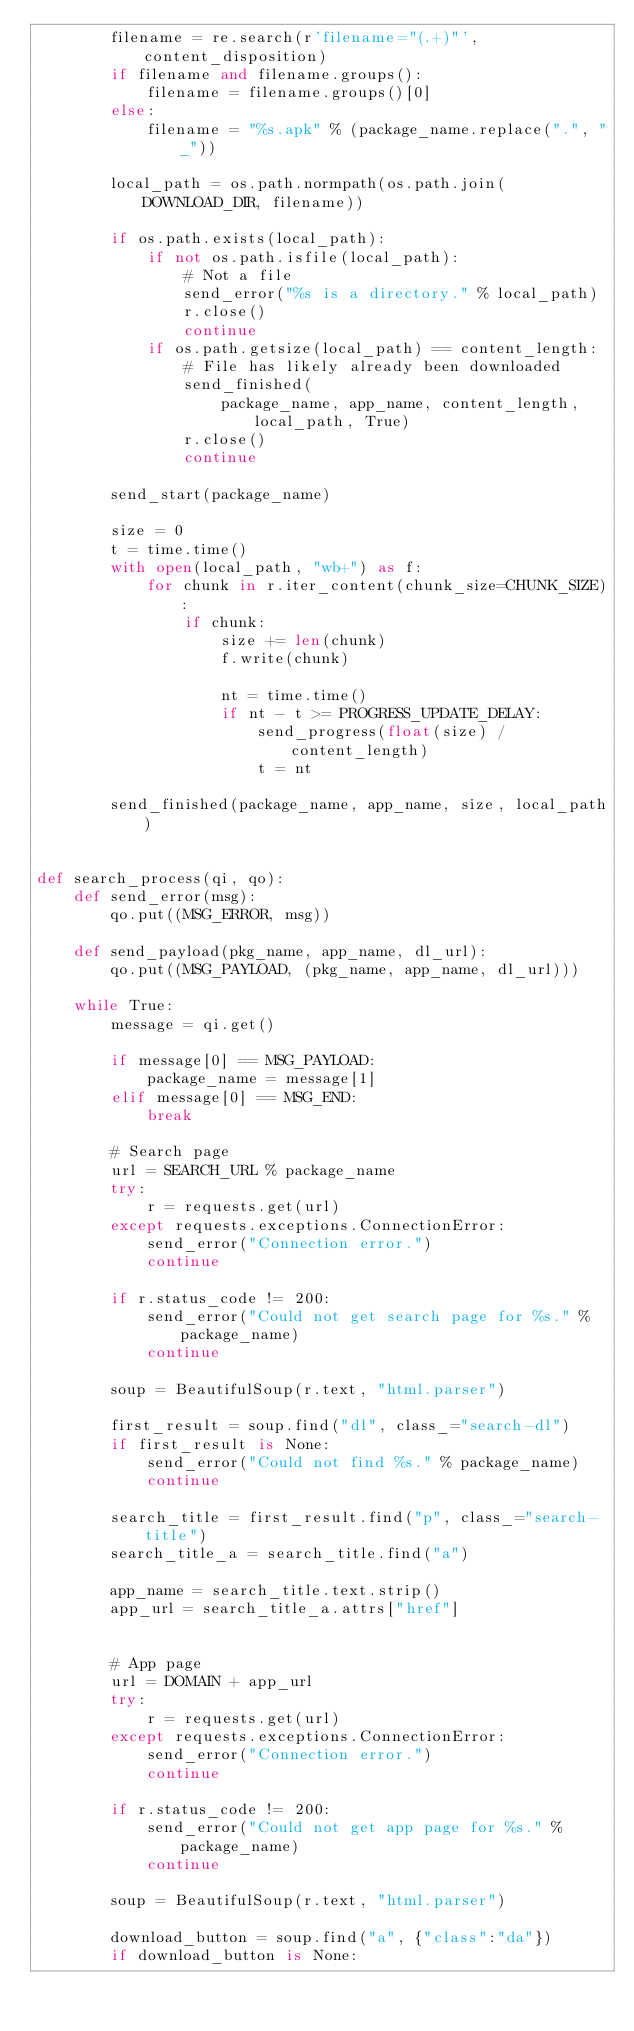<code> <loc_0><loc_0><loc_500><loc_500><_Python_>        filename = re.search(r'filename="(.+)"', content_disposition)
        if filename and filename.groups():
            filename = filename.groups()[0]
        else:
            filename = "%s.apk" % (package_name.replace(".", "_"))

        local_path = os.path.normpath(os.path.join(DOWNLOAD_DIR, filename))

        if os.path.exists(local_path):
            if not os.path.isfile(local_path):
                # Not a file
                send_error("%s is a directory." % local_path)
                r.close()
                continue
            if os.path.getsize(local_path) == content_length:
                # File has likely already been downloaded
                send_finished(
                    package_name, app_name, content_length, local_path, True)
                r.close()
                continue

        send_start(package_name)

        size = 0
        t = time.time()
        with open(local_path, "wb+") as f:
            for chunk in r.iter_content(chunk_size=CHUNK_SIZE):
                if chunk:
                    size += len(chunk)
                    f.write(chunk)

                    nt = time.time()
                    if nt - t >= PROGRESS_UPDATE_DELAY:
                        send_progress(float(size) / content_length)
                        t = nt

        send_finished(package_name, app_name, size, local_path)


def search_process(qi, qo):
    def send_error(msg):
        qo.put((MSG_ERROR, msg))

    def send_payload(pkg_name, app_name, dl_url):
        qo.put((MSG_PAYLOAD, (pkg_name, app_name, dl_url)))

    while True:
        message = qi.get()

        if message[0] == MSG_PAYLOAD:
            package_name = message[1]
        elif message[0] == MSG_END:
            break

        # Search page
        url = SEARCH_URL % package_name
        try:
            r = requests.get(url)
        except requests.exceptions.ConnectionError:
            send_error("Connection error.")
            continue

        if r.status_code != 200:
            send_error("Could not get search page for %s." % package_name)
            continue

        soup = BeautifulSoup(r.text, "html.parser")

        first_result = soup.find("dl", class_="search-dl")
        if first_result is None:
            send_error("Could not find %s." % package_name)
            continue

        search_title = first_result.find("p", class_="search-title")
        search_title_a = search_title.find("a")

        app_name = search_title.text.strip()
        app_url = search_title_a.attrs["href"]


        # App page
        url = DOMAIN + app_url
        try:
            r = requests.get(url)
        except requests.exceptions.ConnectionError:
            send_error("Connection error.")
            continue

        if r.status_code != 200:
            send_error("Could not get app page for %s." % package_name)
            continue

        soup = BeautifulSoup(r.text, "html.parser")

        download_button = soup.find("a", {"class":"da"})
        if download_button is None:</code> 